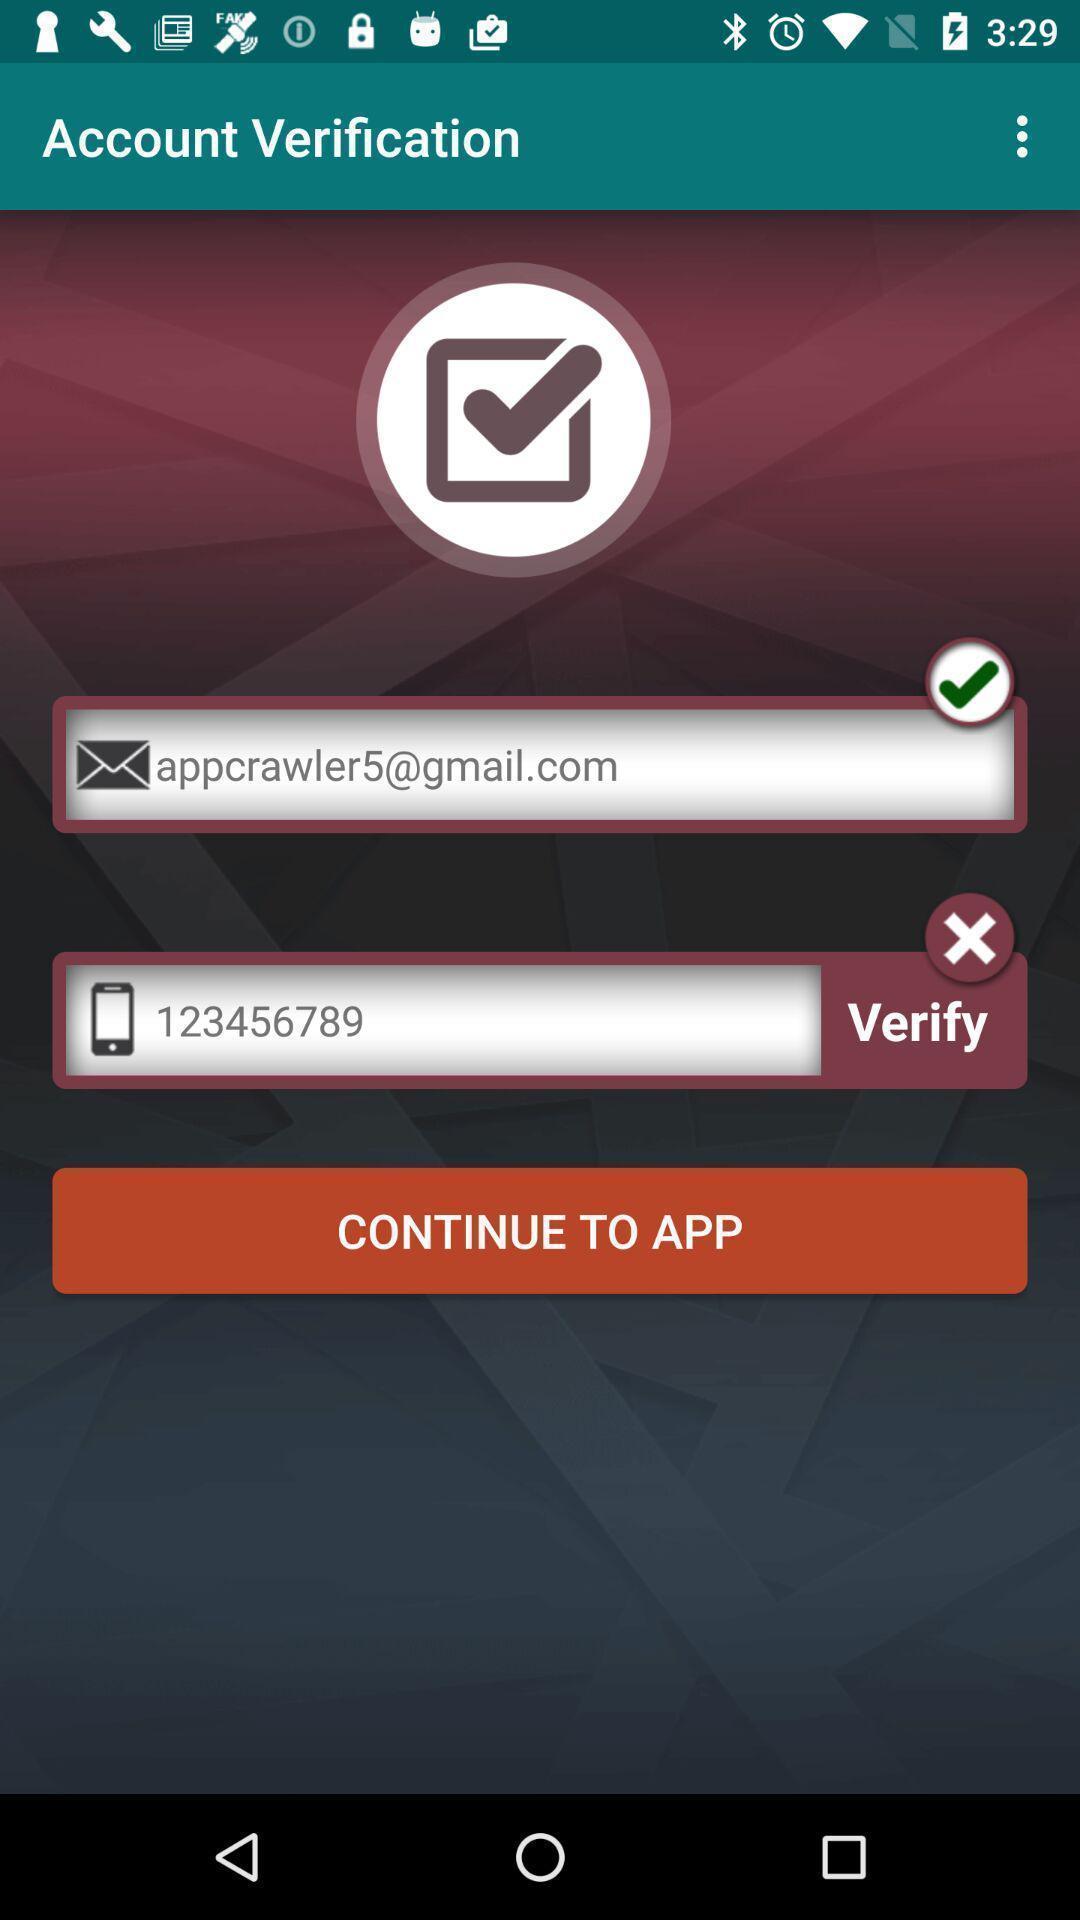Explain what's happening in this screen capture. Wrong sign is displaying at the verify tab. 